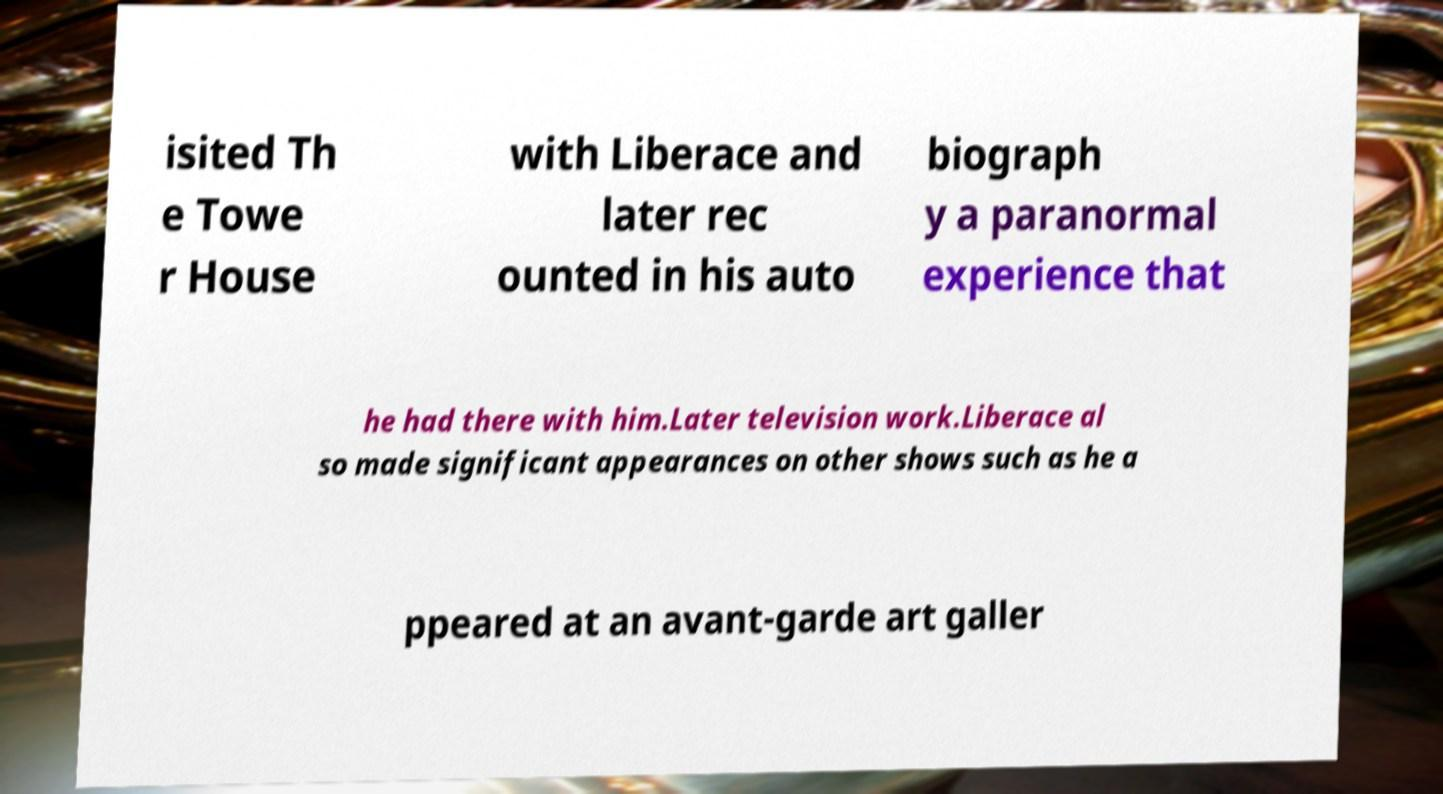I need the written content from this picture converted into text. Can you do that? isited Th e Towe r House with Liberace and later rec ounted in his auto biograph y a paranormal experience that he had there with him.Later television work.Liberace al so made significant appearances on other shows such as he a ppeared at an avant-garde art galler 